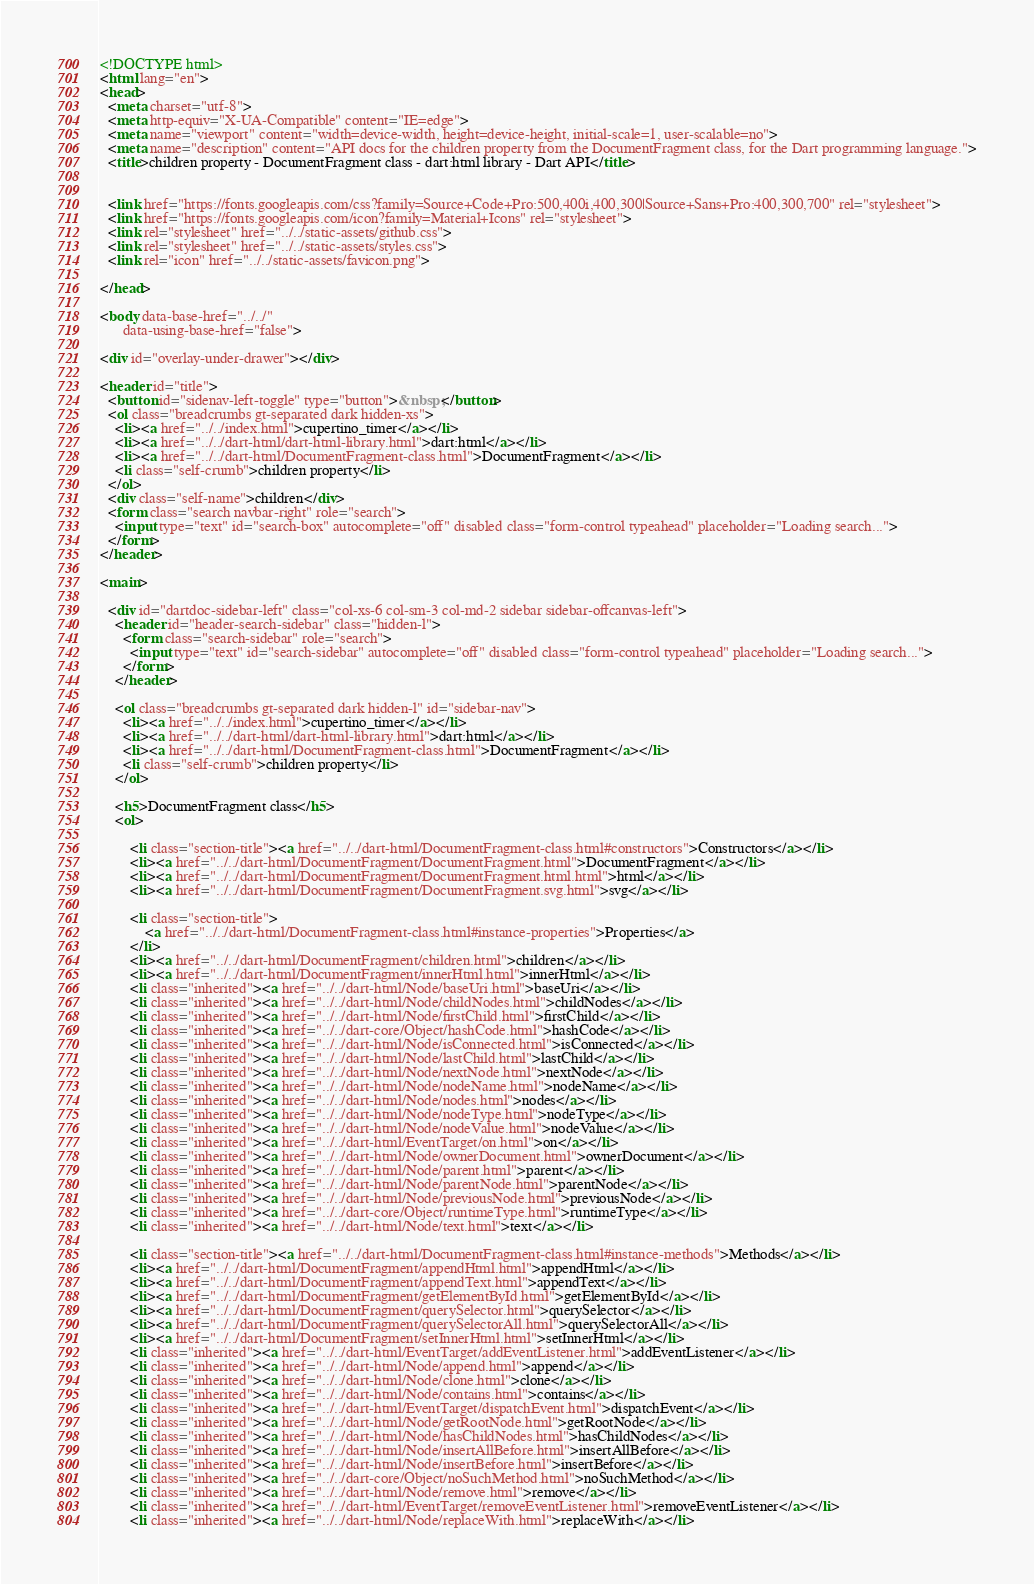<code> <loc_0><loc_0><loc_500><loc_500><_HTML_><!DOCTYPE html>
<html lang="en">
<head>
  <meta charset="utf-8">
  <meta http-equiv="X-UA-Compatible" content="IE=edge">
  <meta name="viewport" content="width=device-width, height=device-height, initial-scale=1, user-scalable=no">
  <meta name="description" content="API docs for the children property from the DocumentFragment class, for the Dart programming language.">
  <title>children property - DocumentFragment class - dart:html library - Dart API</title>

  
  <link href="https://fonts.googleapis.com/css?family=Source+Code+Pro:500,400i,400,300|Source+Sans+Pro:400,300,700" rel="stylesheet">
  <link href="https://fonts.googleapis.com/icon?family=Material+Icons" rel="stylesheet">
  <link rel="stylesheet" href="../../static-assets/github.css">
  <link rel="stylesheet" href="../../static-assets/styles.css">
  <link rel="icon" href="../../static-assets/favicon.png">

</head>

<body data-base-href="../../"
      data-using-base-href="false">

<div id="overlay-under-drawer"></div>

<header id="title">
  <button id="sidenav-left-toggle" type="button">&nbsp;</button>
  <ol class="breadcrumbs gt-separated dark hidden-xs">
    <li><a href="../../index.html">cupertino_timer</a></li>
    <li><a href="../../dart-html/dart-html-library.html">dart:html</a></li>
    <li><a href="../../dart-html/DocumentFragment-class.html">DocumentFragment</a></li>
    <li class="self-crumb">children property</li>
  </ol>
  <div class="self-name">children</div>
  <form class="search navbar-right" role="search">
    <input type="text" id="search-box" autocomplete="off" disabled class="form-control typeahead" placeholder="Loading search...">
  </form>
</header>

<main>

  <div id="dartdoc-sidebar-left" class="col-xs-6 col-sm-3 col-md-2 sidebar sidebar-offcanvas-left">
    <header id="header-search-sidebar" class="hidden-l">
      <form class="search-sidebar" role="search">
        <input type="text" id="search-sidebar" autocomplete="off" disabled class="form-control typeahead" placeholder="Loading search...">
      </form>
    </header>
    
    <ol class="breadcrumbs gt-separated dark hidden-l" id="sidebar-nav">
      <li><a href="../../index.html">cupertino_timer</a></li>
      <li><a href="../../dart-html/dart-html-library.html">dart:html</a></li>
      <li><a href="../../dart-html/DocumentFragment-class.html">DocumentFragment</a></li>
      <li class="self-crumb">children property</li>
    </ol>
    
    <h5>DocumentFragment class</h5>
    <ol>
    
        <li class="section-title"><a href="../../dart-html/DocumentFragment-class.html#constructors">Constructors</a></li>
        <li><a href="../../dart-html/DocumentFragment/DocumentFragment.html">DocumentFragment</a></li>
        <li><a href="../../dart-html/DocumentFragment/DocumentFragment.html.html">html</a></li>
        <li><a href="../../dart-html/DocumentFragment/DocumentFragment.svg.html">svg</a></li>
    
        <li class="section-title">
            <a href="../../dart-html/DocumentFragment-class.html#instance-properties">Properties</a>
        </li>
        <li><a href="../../dart-html/DocumentFragment/children.html">children</a></li>
        <li><a href="../../dart-html/DocumentFragment/innerHtml.html">innerHtml</a></li>
        <li class="inherited"><a href="../../dart-html/Node/baseUri.html">baseUri</a></li>
        <li class="inherited"><a href="../../dart-html/Node/childNodes.html">childNodes</a></li>
        <li class="inherited"><a href="../../dart-html/Node/firstChild.html">firstChild</a></li>
        <li class="inherited"><a href="../../dart-core/Object/hashCode.html">hashCode</a></li>
        <li class="inherited"><a href="../../dart-html/Node/isConnected.html">isConnected</a></li>
        <li class="inherited"><a href="../../dart-html/Node/lastChild.html">lastChild</a></li>
        <li class="inherited"><a href="../../dart-html/Node/nextNode.html">nextNode</a></li>
        <li class="inherited"><a href="../../dart-html/Node/nodeName.html">nodeName</a></li>
        <li class="inherited"><a href="../../dart-html/Node/nodes.html">nodes</a></li>
        <li class="inherited"><a href="../../dart-html/Node/nodeType.html">nodeType</a></li>
        <li class="inherited"><a href="../../dart-html/Node/nodeValue.html">nodeValue</a></li>
        <li class="inherited"><a href="../../dart-html/EventTarget/on.html">on</a></li>
        <li class="inherited"><a href="../../dart-html/Node/ownerDocument.html">ownerDocument</a></li>
        <li class="inherited"><a href="../../dart-html/Node/parent.html">parent</a></li>
        <li class="inherited"><a href="../../dart-html/Node/parentNode.html">parentNode</a></li>
        <li class="inherited"><a href="../../dart-html/Node/previousNode.html">previousNode</a></li>
        <li class="inherited"><a href="../../dart-core/Object/runtimeType.html">runtimeType</a></li>
        <li class="inherited"><a href="../../dart-html/Node/text.html">text</a></li>
    
        <li class="section-title"><a href="../../dart-html/DocumentFragment-class.html#instance-methods">Methods</a></li>
        <li><a href="../../dart-html/DocumentFragment/appendHtml.html">appendHtml</a></li>
        <li><a href="../../dart-html/DocumentFragment/appendText.html">appendText</a></li>
        <li><a href="../../dart-html/DocumentFragment/getElementById.html">getElementById</a></li>
        <li><a href="../../dart-html/DocumentFragment/querySelector.html">querySelector</a></li>
        <li><a href="../../dart-html/DocumentFragment/querySelectorAll.html">querySelectorAll</a></li>
        <li><a href="../../dart-html/DocumentFragment/setInnerHtml.html">setInnerHtml</a></li>
        <li class="inherited"><a href="../../dart-html/EventTarget/addEventListener.html">addEventListener</a></li>
        <li class="inherited"><a href="../../dart-html/Node/append.html">append</a></li>
        <li class="inherited"><a href="../../dart-html/Node/clone.html">clone</a></li>
        <li class="inherited"><a href="../../dart-html/Node/contains.html">contains</a></li>
        <li class="inherited"><a href="../../dart-html/EventTarget/dispatchEvent.html">dispatchEvent</a></li>
        <li class="inherited"><a href="../../dart-html/Node/getRootNode.html">getRootNode</a></li>
        <li class="inherited"><a href="../../dart-html/Node/hasChildNodes.html">hasChildNodes</a></li>
        <li class="inherited"><a href="../../dart-html/Node/insertAllBefore.html">insertAllBefore</a></li>
        <li class="inherited"><a href="../../dart-html/Node/insertBefore.html">insertBefore</a></li>
        <li class="inherited"><a href="../../dart-core/Object/noSuchMethod.html">noSuchMethod</a></li>
        <li class="inherited"><a href="../../dart-html/Node/remove.html">remove</a></li>
        <li class="inherited"><a href="../../dart-html/EventTarget/removeEventListener.html">removeEventListener</a></li>
        <li class="inherited"><a href="../../dart-html/Node/replaceWith.html">replaceWith</a></li></code> 